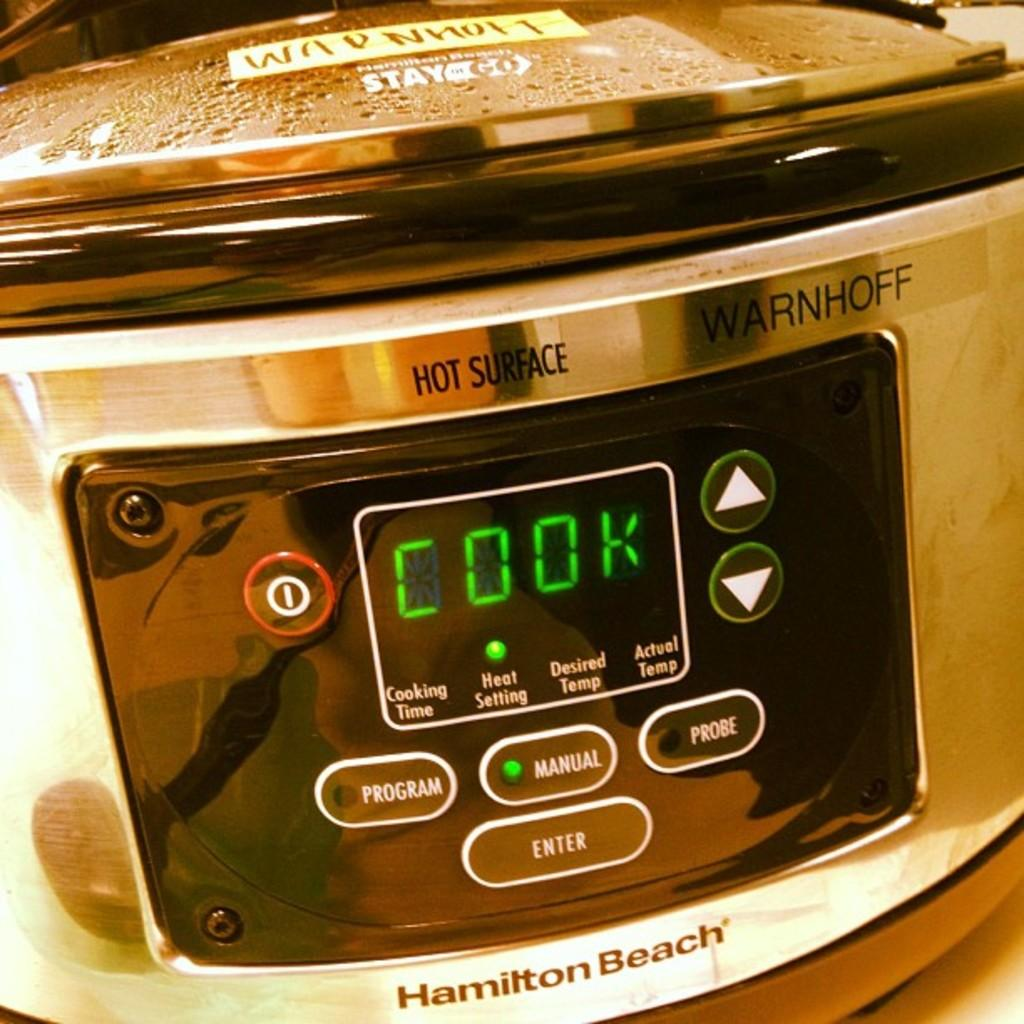<image>
Provide a brief description of the given image. A Hamilton Beach digital silver colored slow cooker. 